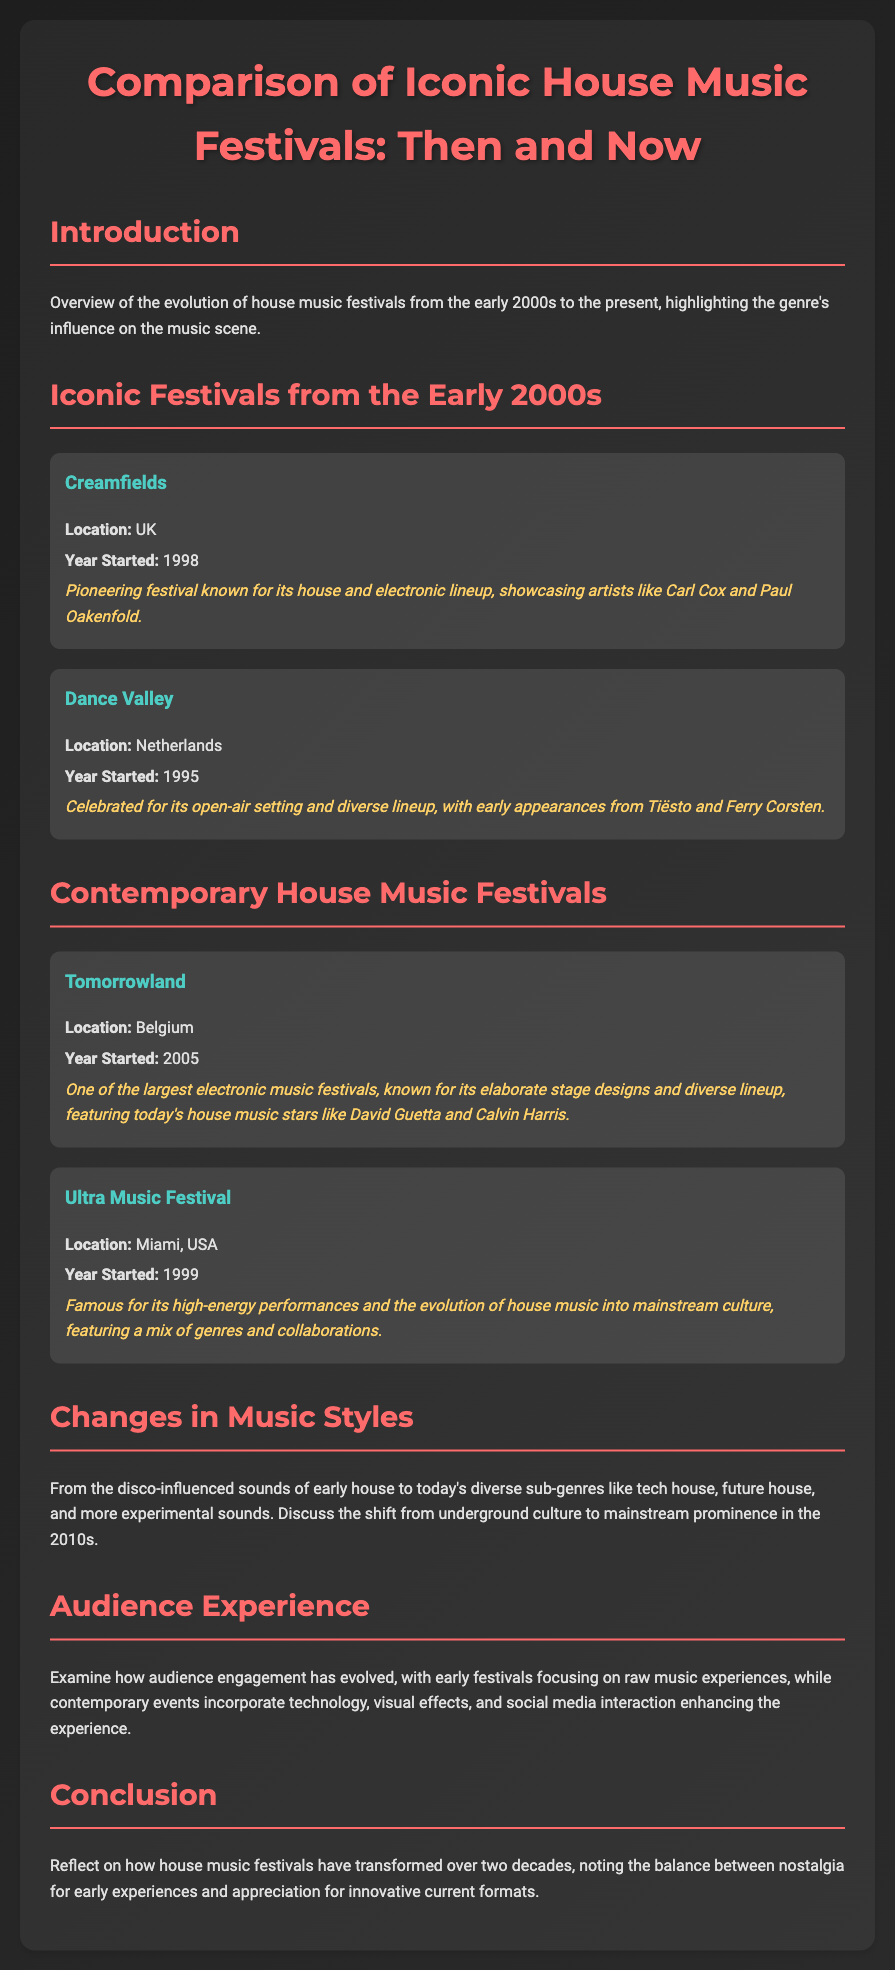What is the location of Creamfields? Creamfields is located in the UK, as mentioned in the document.
Answer: UK When did the Dance Valley festival start? Dance Valley started in 1995, which is specified in the document.
Answer: 1995 Which festival is known for its elaborate stage designs? The document states that Tomorrowland is known for its elaborate stage designs.
Answer: Tomorrowland What genre of music has seen a shift from underground culture to mainstream prominence in the 2010s? The document indicates that house music has evolved from underground culture to mainstream prominence.
Answer: House music What is highlighted about Ultra Music Festival's performances? The document highlights Ultra Music Festival for its high-energy performances.
Answer: High-energy performances How does the audience experience at contemporary events differ from early festivals? The document mentions that contemporary events incorporate technology and visual effects, enhancing the experience, unlike early festivals.
Answer: Technology and visual effects What two artists are mentioned in connection with Tomorrowland? The document lists David Guetta and Calvin Harris as artists featured at Tomorrowland.
Answer: David Guetta and Calvin Harris What year did Tomorrowland start? The document specifies that Tomorrowland started in 2005.
Answer: 2005 